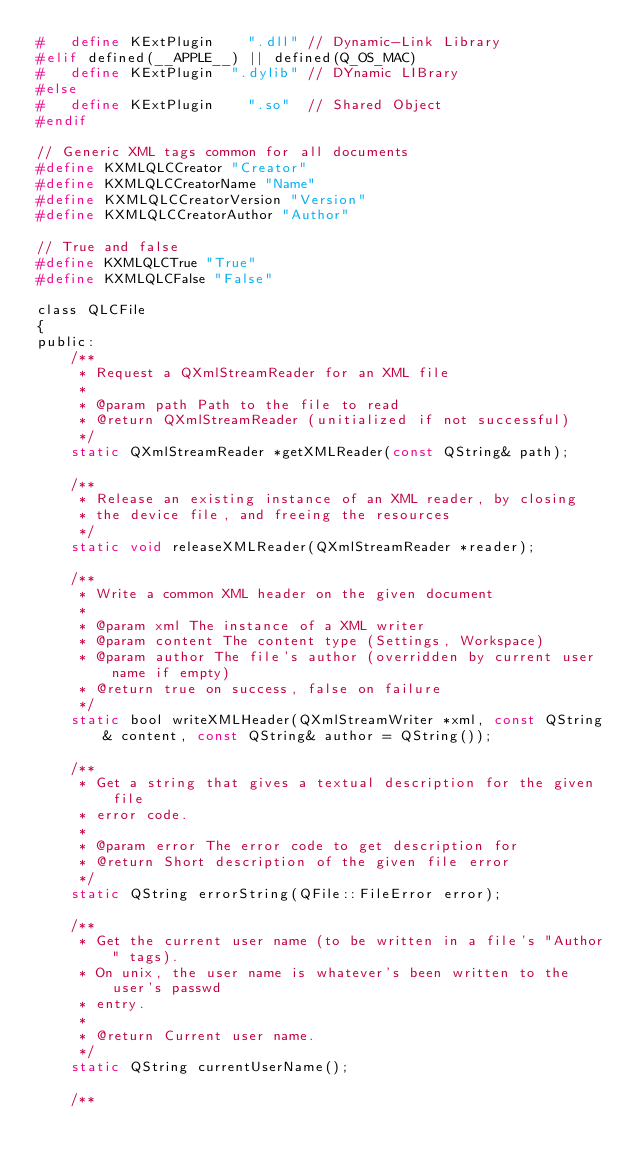Convert code to text. <code><loc_0><loc_0><loc_500><loc_500><_C_>#   define KExtPlugin    ".dll" // Dynamic-Link Library
#elif defined(__APPLE__) || defined(Q_OS_MAC)
#   define KExtPlugin  ".dylib" // DYnamic LIBrary
#else
#   define KExtPlugin    ".so"  // Shared Object
#endif

// Generic XML tags common for all documents
#define KXMLQLCCreator "Creator"
#define KXMLQLCCreatorName "Name"
#define KXMLQLCCreatorVersion "Version"
#define KXMLQLCCreatorAuthor "Author"

// True and false
#define KXMLQLCTrue "True"
#define KXMLQLCFalse "False"

class QLCFile
{
public:
    /**
     * Request a QXmlStreamReader for an XML file
     *
     * @param path Path to the file to read
     * @return QXmlStreamReader (unitialized if not successful)
     */
    static QXmlStreamReader *getXMLReader(const QString& path);

    /**
     * Release an existing instance of an XML reader, by closing
     * the device file, and freeing the resources
     */
    static void releaseXMLReader(QXmlStreamReader *reader);

    /**
     * Write a common XML header on the given document
     *
     * @param xml The instance of a XML writer
     * @param content The content type (Settings, Workspace)
     * @param author The file's author (overridden by current user name if empty)
     * @return true on success, false on failure
     */
    static bool writeXMLHeader(QXmlStreamWriter *xml, const QString& content, const QString& author = QString());

    /**
     * Get a string that gives a textual description for the given file
     * error code.
     *
     * @param error The error code to get description for
     * @return Short description of the given file error
     */
    static QString errorString(QFile::FileError error);

    /**
     * Get the current user name (to be written in a file's "Author" tags).
     * On unix, the user name is whatever's been written to the user's passwd
     * entry.
     *
     * @return Current user name.
     */
    static QString currentUserName();

    /**</code> 